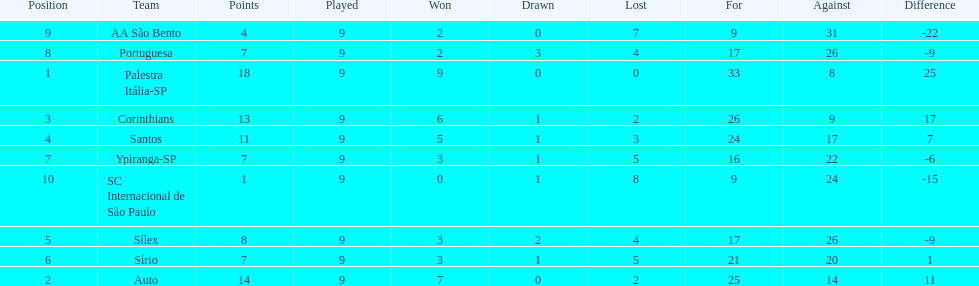In 1926 brazilian football,aside from the first place team, what other teams had winning records? Auto, Corinthians, Santos. 